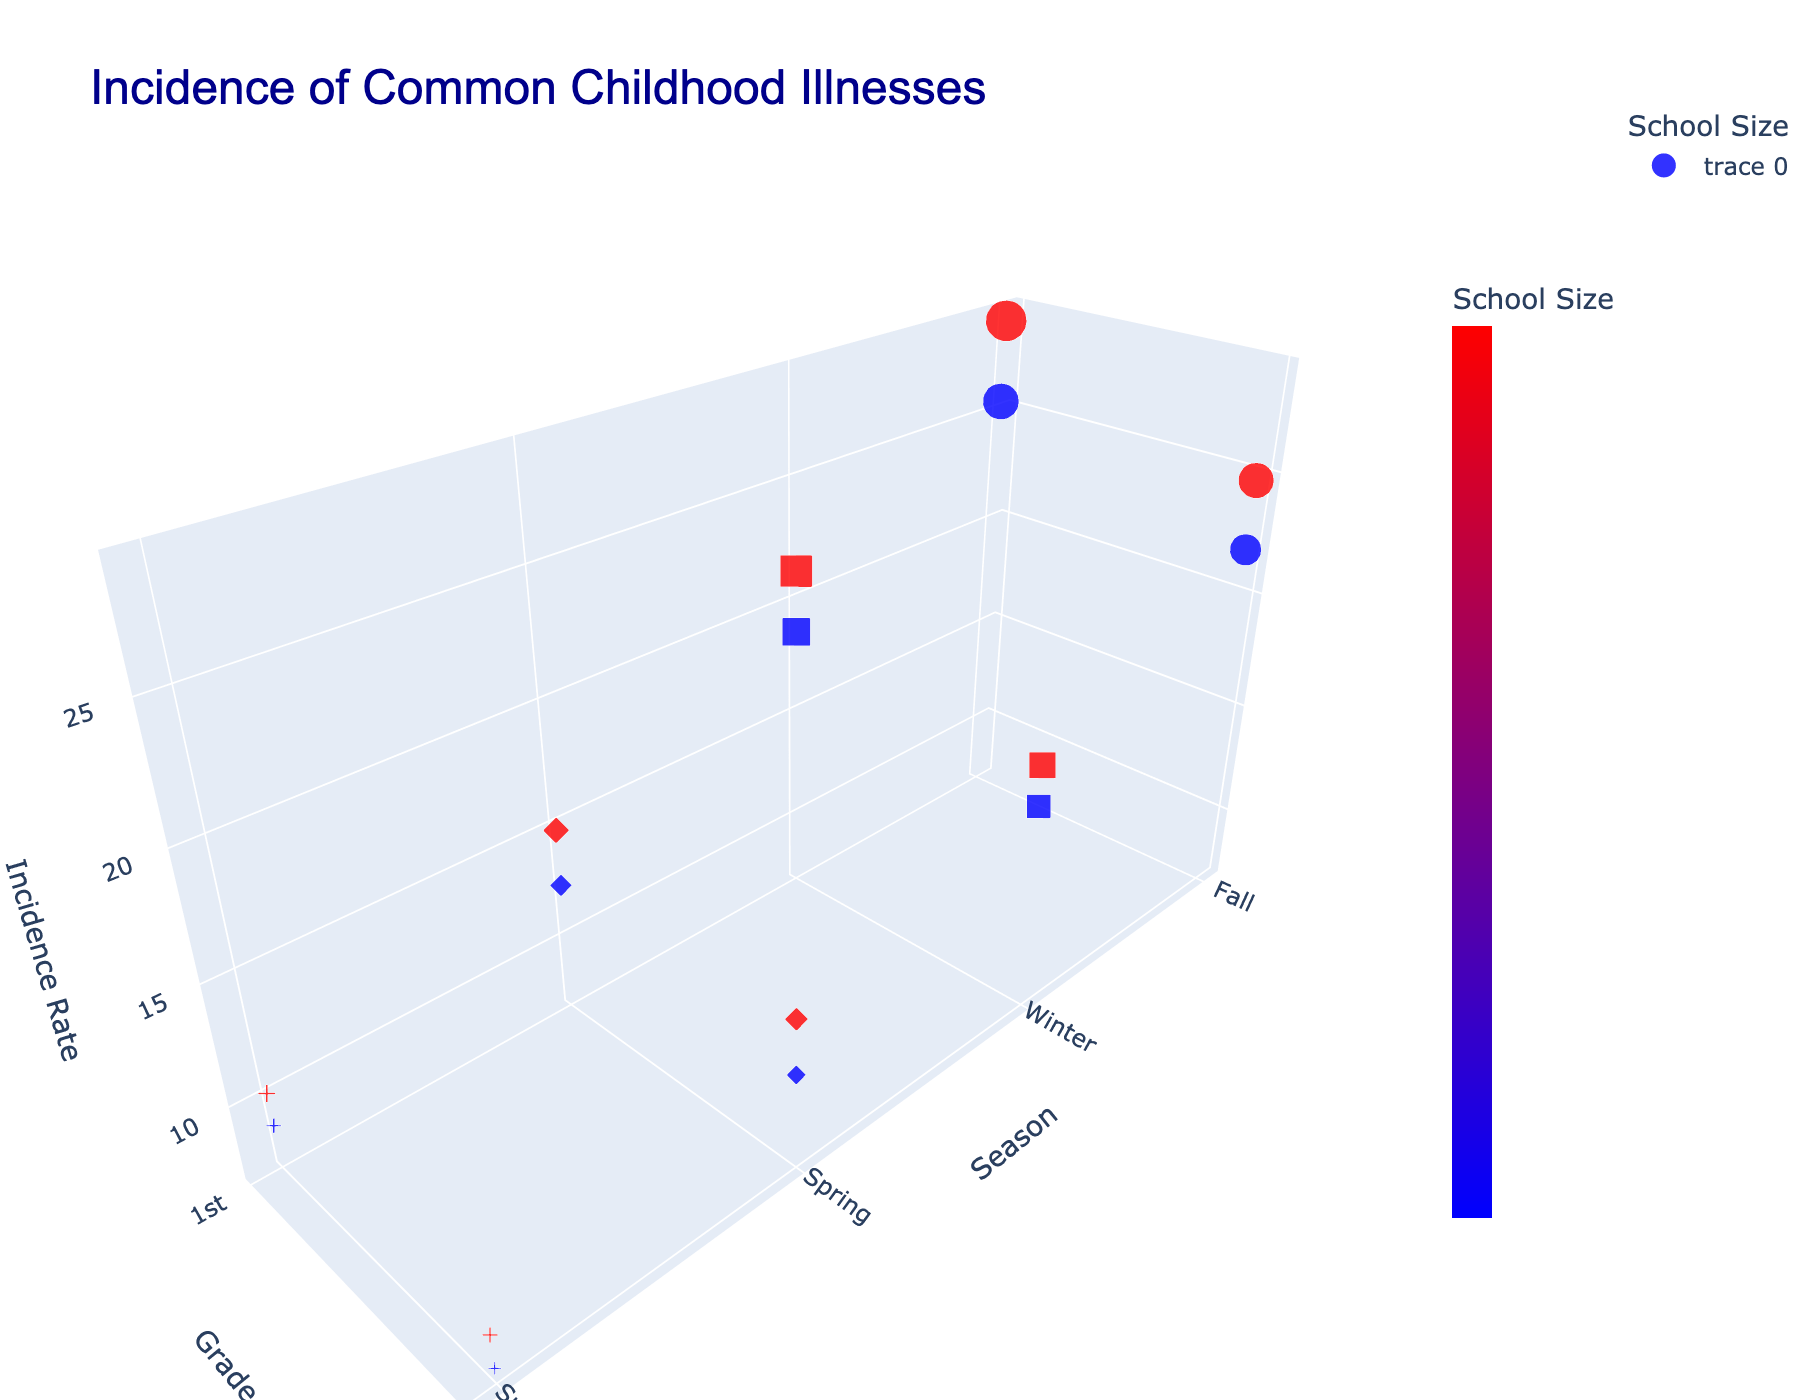What's the title of the figure? The title is usually displayed at the top of the figure. Here, it reads "Incidence of Common Childhood Illnesses."
Answer: Incidence of Common Childhood Illnesses How many different seasons are represented in the figure? The x-axis is labeled "Season" and has four distinct ticks representing the four seasons: Fall, Winter, Spring, and Summer.
Answer: Four Which grade level is associated with the lowest incidence rate of Gastroenteritis in a small school? To find this, locate the symbols representing Gastroenteritis ('cross' shape), and then look for the smaller values on the z-axis for small schools (blue color). The 5th-grade level has the lowest incidence rate of 7.5.
Answer: 5th grade What illness has the largest incidence rate for 1st graders in large schools? Find the data points for 1st grade (y-axis label "1st") that are red (large school). Then check which has the highest value on the z-axis. The largest incidence rate for 1st graders in large schools is the Common Cold at 28.7.
Answer: Common Cold Between small and large schools, which had a higher incidence rate of Flu during winter for 5th graders? Identify the data points for seasonal illness (Winter) for 5th graders, and compare the z-axis values for blue (small school) and red (large school) points. Large schools had a higher incidence rate at 17.5 compared to 15.8 for small schools.
Answer: Large schools How does the incidence rate of Allergies in Spring differ between 1st graders and 5th graders in large schools? Locate the Allergies points for Spring (diamond shape) and compare the z-axis values for 1st and 5th graders in red (large school). 1st graders have a rate of 14.8 and 5th graders have 13.2. The difference is 14.8 - 13.2 = 1.6.
Answer: 1.6 Which illness in any season has the smallest overall incidence rate, and what is that rate? Look for the lowest point on the z-axis across all data points. The lowest value is for Gastroenteritis in the 5th grade during Summer in small schools, with an incidence rate of 7.5.
Answer: Gastroenteritis, 7.5 What is the combined average incidence rate of Common Cold in fall for both school sizes? Sum the incidence rates of Common Cold for both small (25.3) and large (28.7) schools and divide by 2. (25.3 + 28.7) / 2 = 27.
Answer: 27 During which season do allergies have the highest incidence rate, and what school size and grade does this correspond to? Identify all data points related to Allergies (diamond shape) and find the highest value on the z-axis. Allergies during Spring for 1st graders in large schools have the highest incidence rate of 14.8.
Answer: Spring, large school, 1st grade 